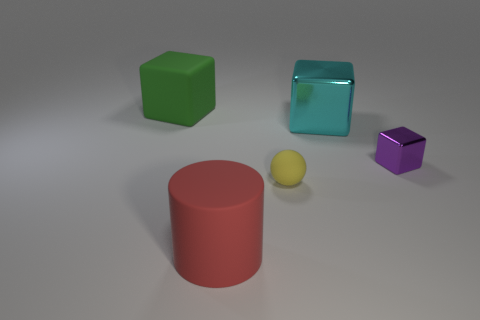There is a big thing that is on the left side of the yellow object and behind the big matte cylinder; what color is it? green 